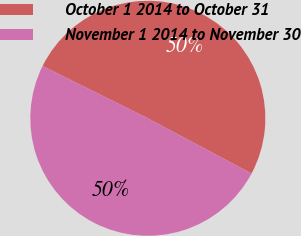Convert chart to OTSL. <chart><loc_0><loc_0><loc_500><loc_500><pie_chart><fcel>October 1 2014 to October 31<fcel>November 1 2014 to November 30<nl><fcel>50.45%<fcel>49.55%<nl></chart> 